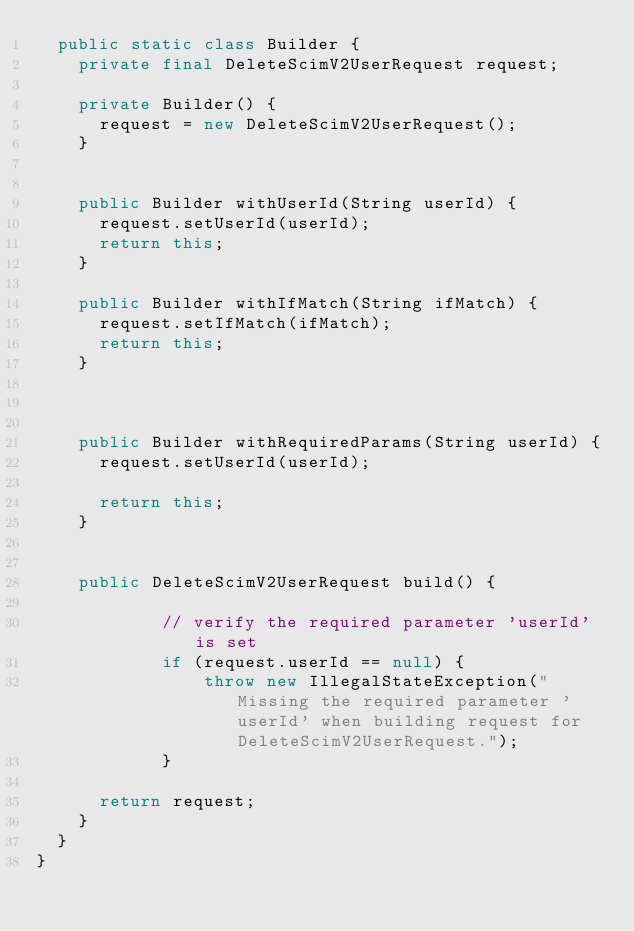<code> <loc_0><loc_0><loc_500><loc_500><_Java_>	public static class Builder {
		private final DeleteScimV2UserRequest request;

		private Builder() {
			request = new DeleteScimV2UserRequest();
		}

		
		public Builder withUserId(String userId) {
			request.setUserId(userId);
			return this;
		}
		
		public Builder withIfMatch(String ifMatch) {
			request.setIfMatch(ifMatch);
			return this;
		}
		

		
		public Builder withRequiredParams(String userId) {
			request.setUserId(userId);
			
			return this;
		}
		

		public DeleteScimV2UserRequest build() {
            
            // verify the required parameter 'userId' is set
            if (request.userId == null) {
                throw new IllegalStateException("Missing the required parameter 'userId' when building request for DeleteScimV2UserRequest.");
            }
            
			return request;
		}
	}
}
</code> 